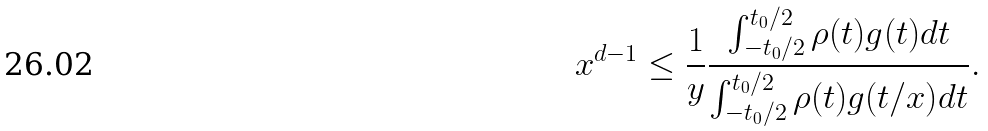Convert formula to latex. <formula><loc_0><loc_0><loc_500><loc_500>x ^ { d - 1 } \leq \frac { 1 } { y } \frac { \int _ { - t _ { 0 } / 2 } ^ { t _ { 0 } / 2 } \rho ( t ) g ( t ) d t } { \int _ { - t _ { 0 } / 2 } ^ { t _ { 0 } / 2 } \rho ( t ) g ( t / x ) d t } .</formula> 